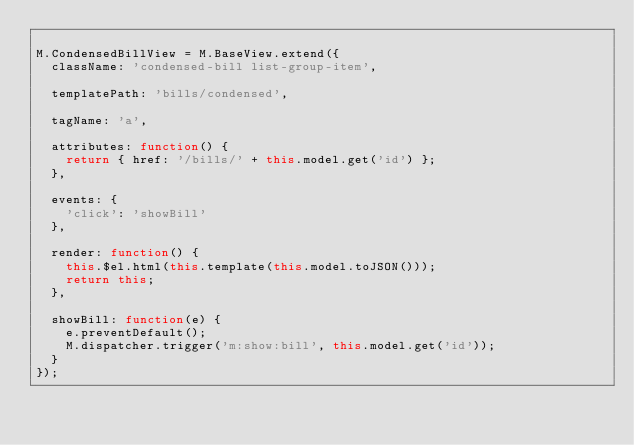Convert code to text. <code><loc_0><loc_0><loc_500><loc_500><_JavaScript_>
M.CondensedBillView = M.BaseView.extend({
  className: 'condensed-bill list-group-item',

  templatePath: 'bills/condensed',

  tagName: 'a',

  attributes: function() {
    return { href: '/bills/' + this.model.get('id') };
  },

  events: {
    'click': 'showBill'
  },

  render: function() {
    this.$el.html(this.template(this.model.toJSON()));
    return this;
  },

  showBill: function(e) {
    e.preventDefault();
    M.dispatcher.trigger('m:show:bill', this.model.get('id'));
  }
});
</code> 